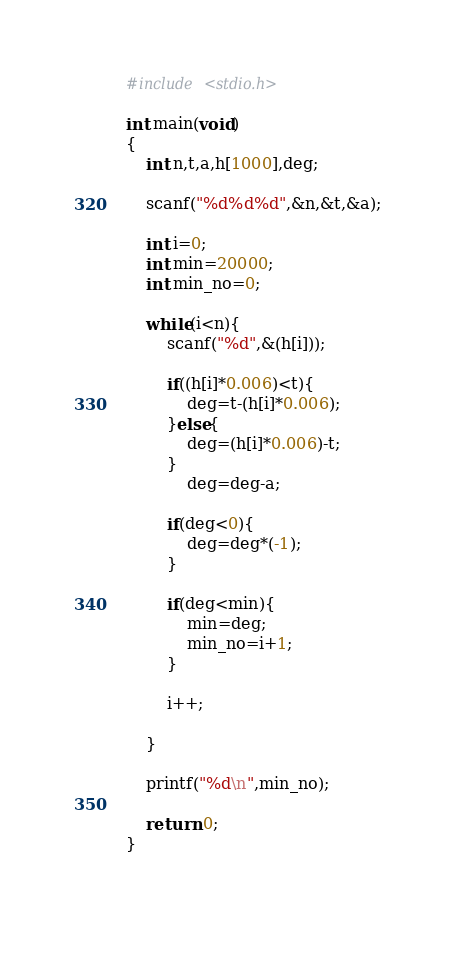Convert code to text. <code><loc_0><loc_0><loc_500><loc_500><_C_>#include <stdio.h>

int main(void)
{
	int n,t,a,h[1000],deg;
	
	scanf("%d%d%d",&n,&t,&a);
	
	int i=0;
	int min=20000;
	int min_no=0;
	
	while(i<n){
		scanf("%d",&(h[i]));
		
		if((h[i]*0.006)<t){
			deg=t-(h[i]*0.006);
		}else{
			deg=(h[i]*0.006)-t;
		}
			deg=deg-a;
		
		if(deg<0){
			deg=deg*(-1);
		}
		
		if(deg<min){
			min=deg;
			min_no=i+1;
		}
	
		i++;
	
	}
	
	printf("%d\n",min_no);

	return 0;
}
		
	</code> 